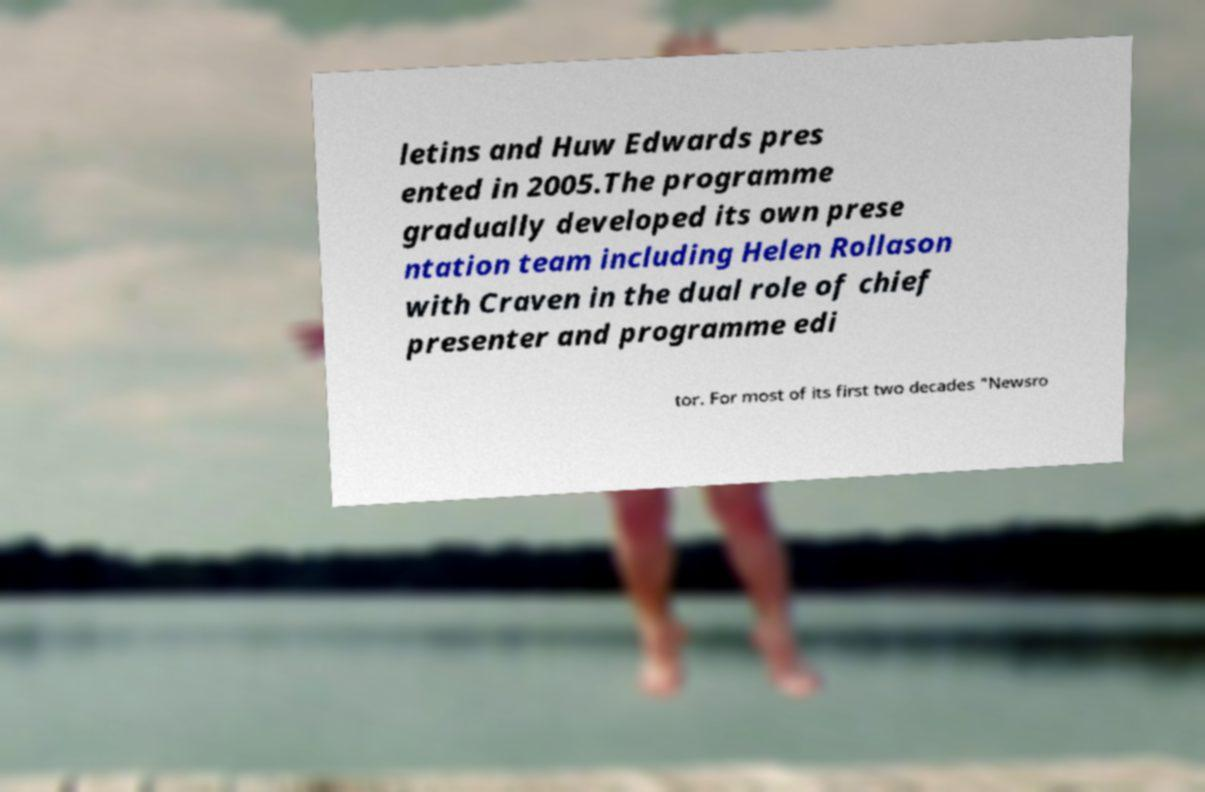Can you accurately transcribe the text from the provided image for me? letins and Huw Edwards pres ented in 2005.The programme gradually developed its own prese ntation team including Helen Rollason with Craven in the dual role of chief presenter and programme edi tor. For most of its first two decades "Newsro 